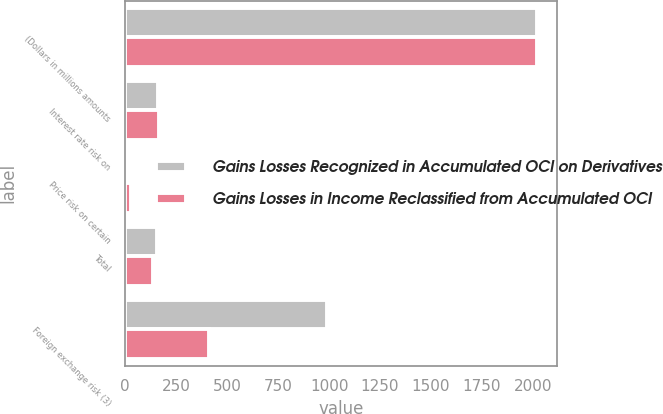Convert chart to OTSL. <chart><loc_0><loc_0><loc_500><loc_500><stacked_bar_chart><ecel><fcel>(Dollars in millions amounts<fcel>Interest rate risk on<fcel>Price risk on certain<fcel>Total<fcel>Foreign exchange risk (3)<nl><fcel>Gains Losses Recognized in Accumulated OCI on Derivatives<fcel>2018<fcel>159<fcel>4<fcel>155<fcel>989<nl><fcel>Gains Losses in Income Reclassified from Accumulated OCI<fcel>2018<fcel>165<fcel>27<fcel>138<fcel>411<nl></chart> 